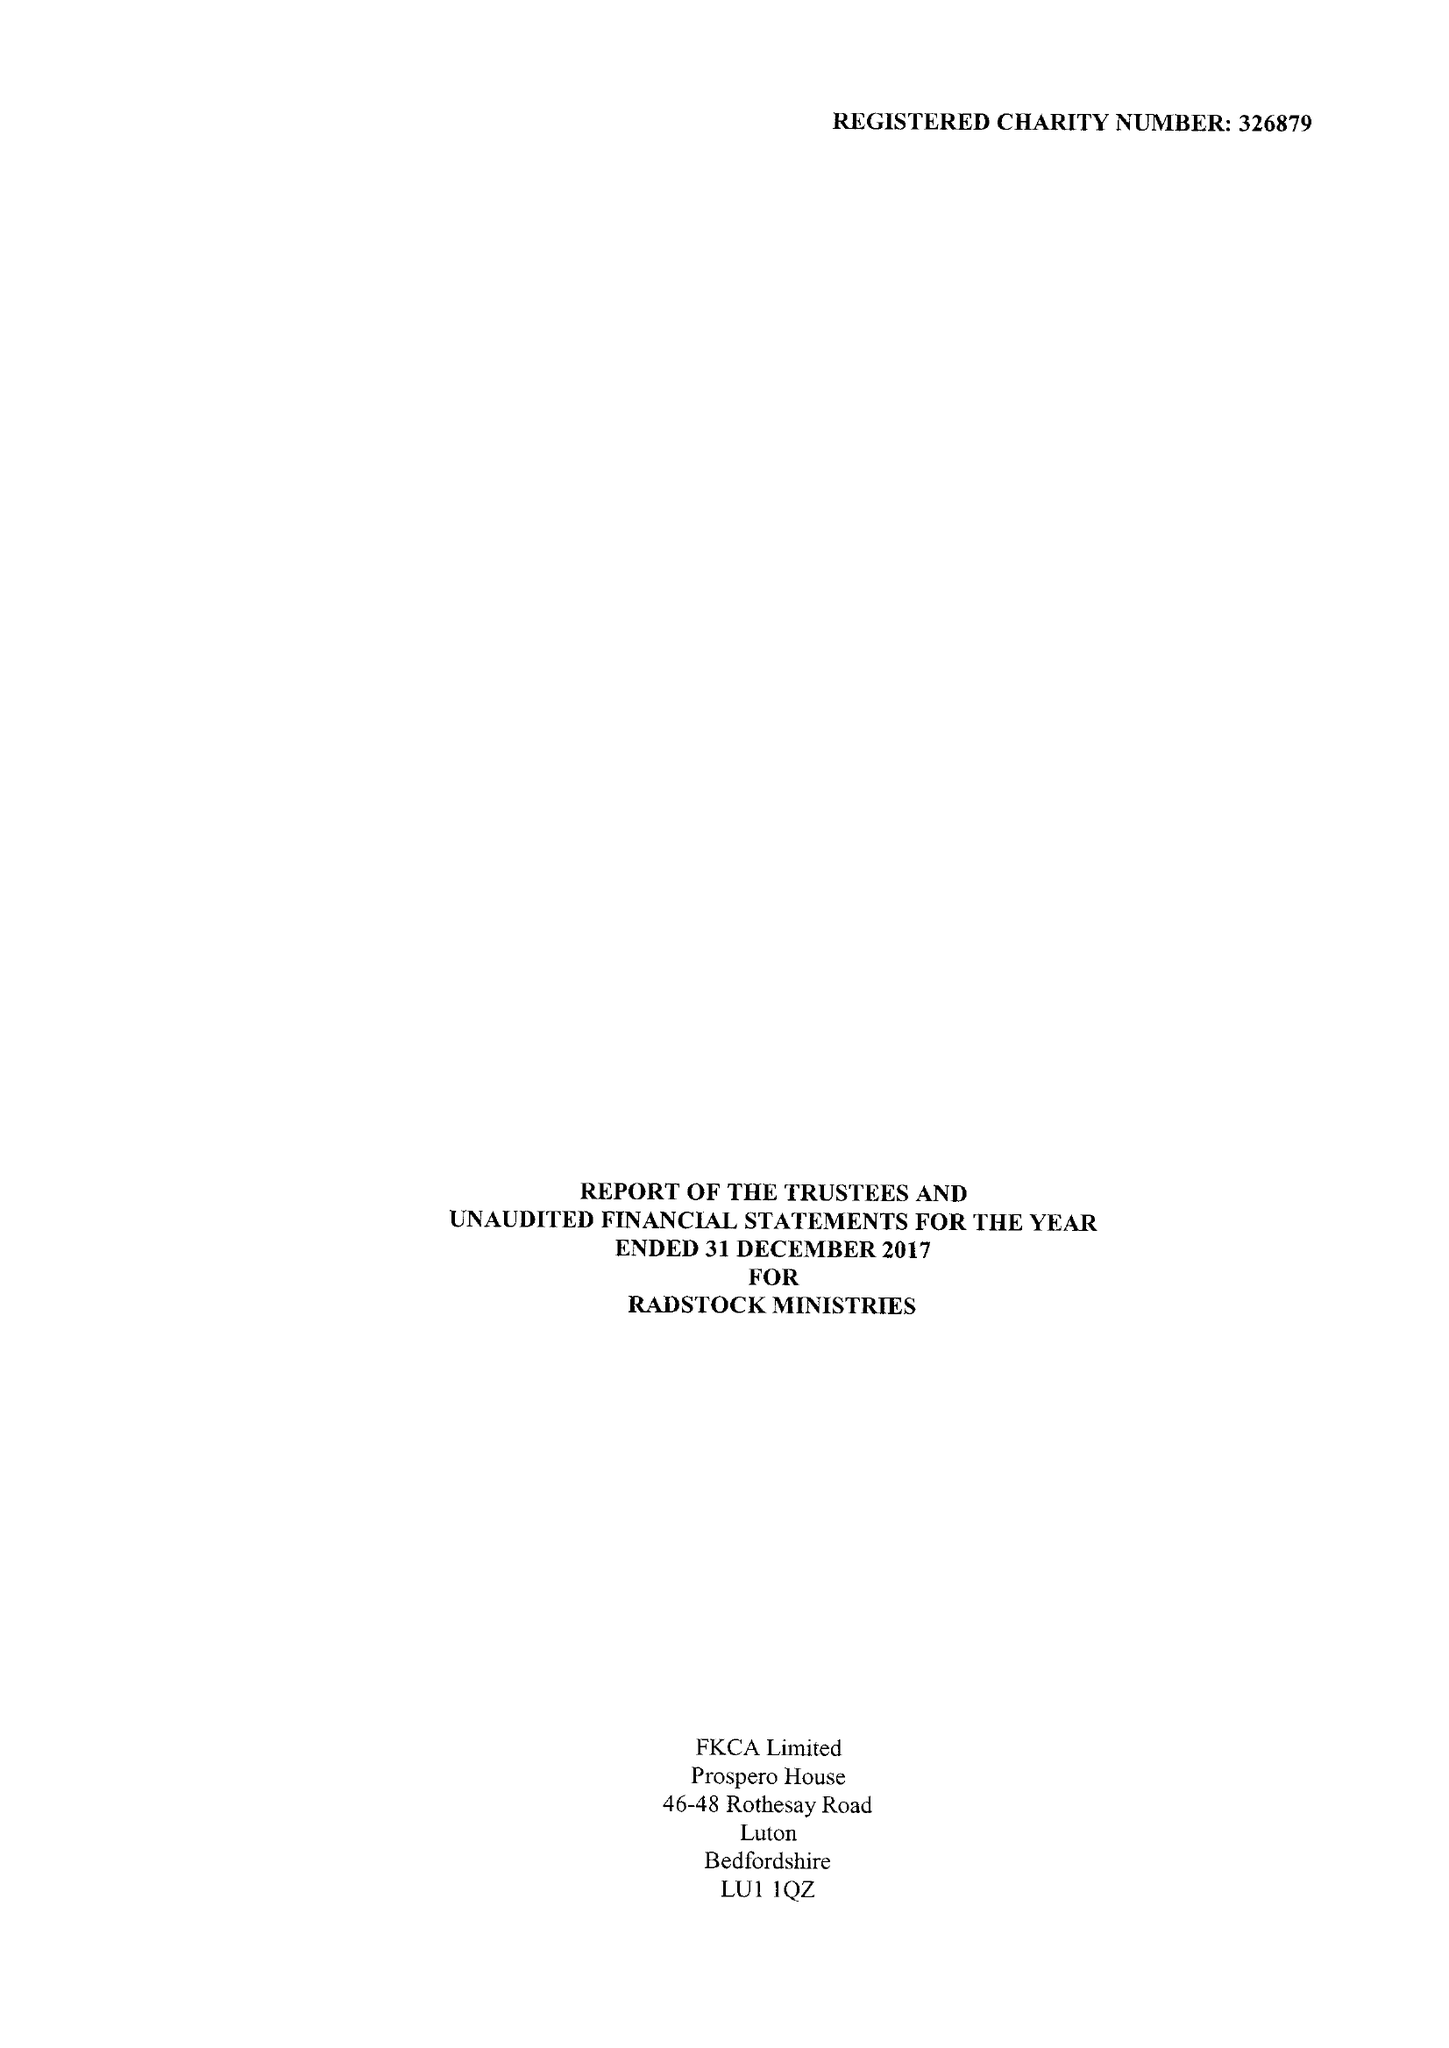What is the value for the charity_number?
Answer the question using a single word or phrase. 326879 